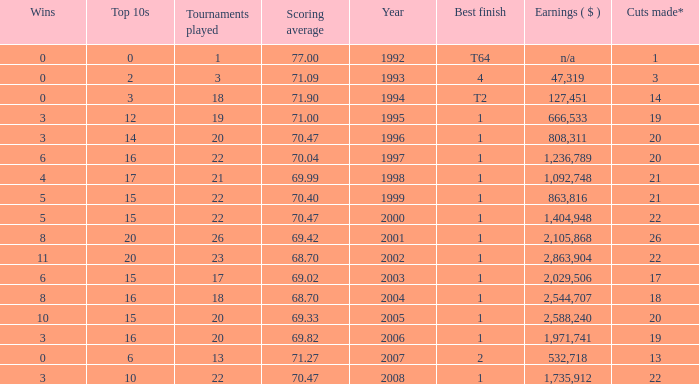Tell me the highest wins for year less than 2000 and best finish of 4 and tournaments played less than 3 None. 